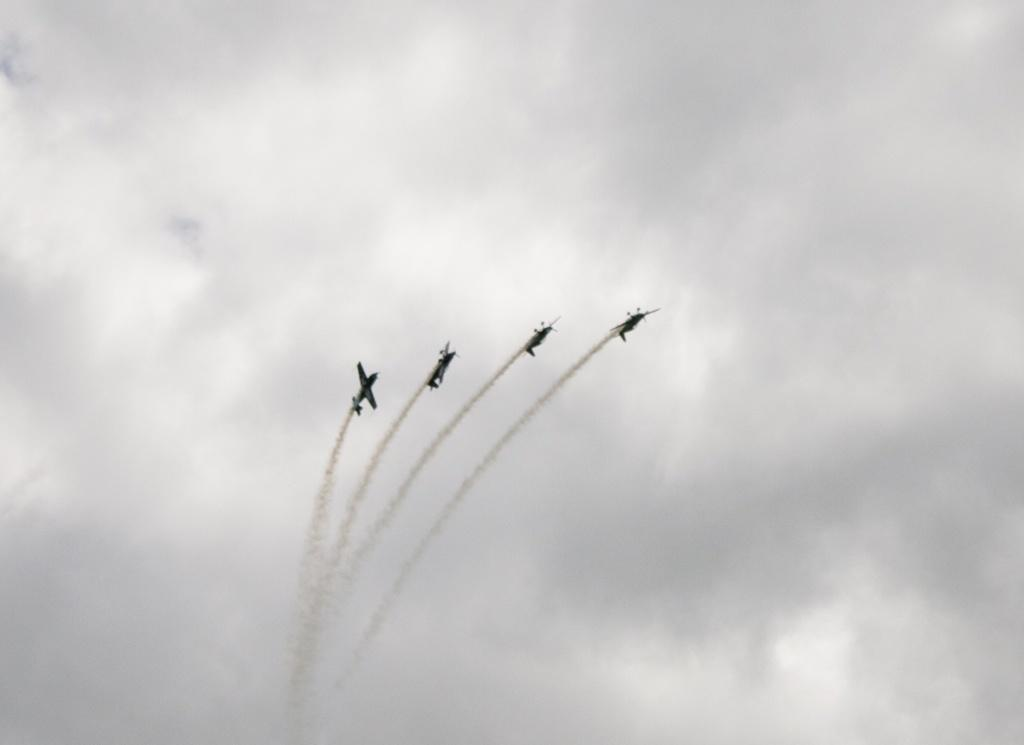What is the main subject of the image? The main subject of the image is four jets. What are the jets doing in the image? The jets are flying in the image. What can be seen coming out of the jets? The jets are exhaling smoke in the image. What is visible in the background of the image? There is a sky visible in the background of the image. What can be observed in the sky? Clouds are present in the sky. Can you tell me how many hens are sitting on the jets in the image? There are no hens present in the image; it features four jets flying and exhaling smoke. What type of interest does the pilot of the first jet have in the image? There is no information about the pilot's interests in the image, as it only shows the jets flying and exhaling smoke. 